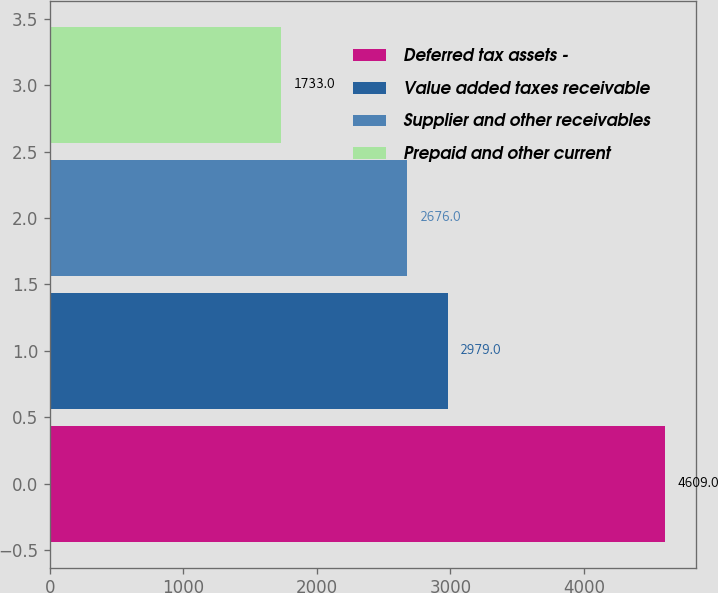<chart> <loc_0><loc_0><loc_500><loc_500><bar_chart><fcel>Deferred tax assets -<fcel>Value added taxes receivable<fcel>Supplier and other receivables<fcel>Prepaid and other current<nl><fcel>4609<fcel>2979<fcel>2676<fcel>1733<nl></chart> 